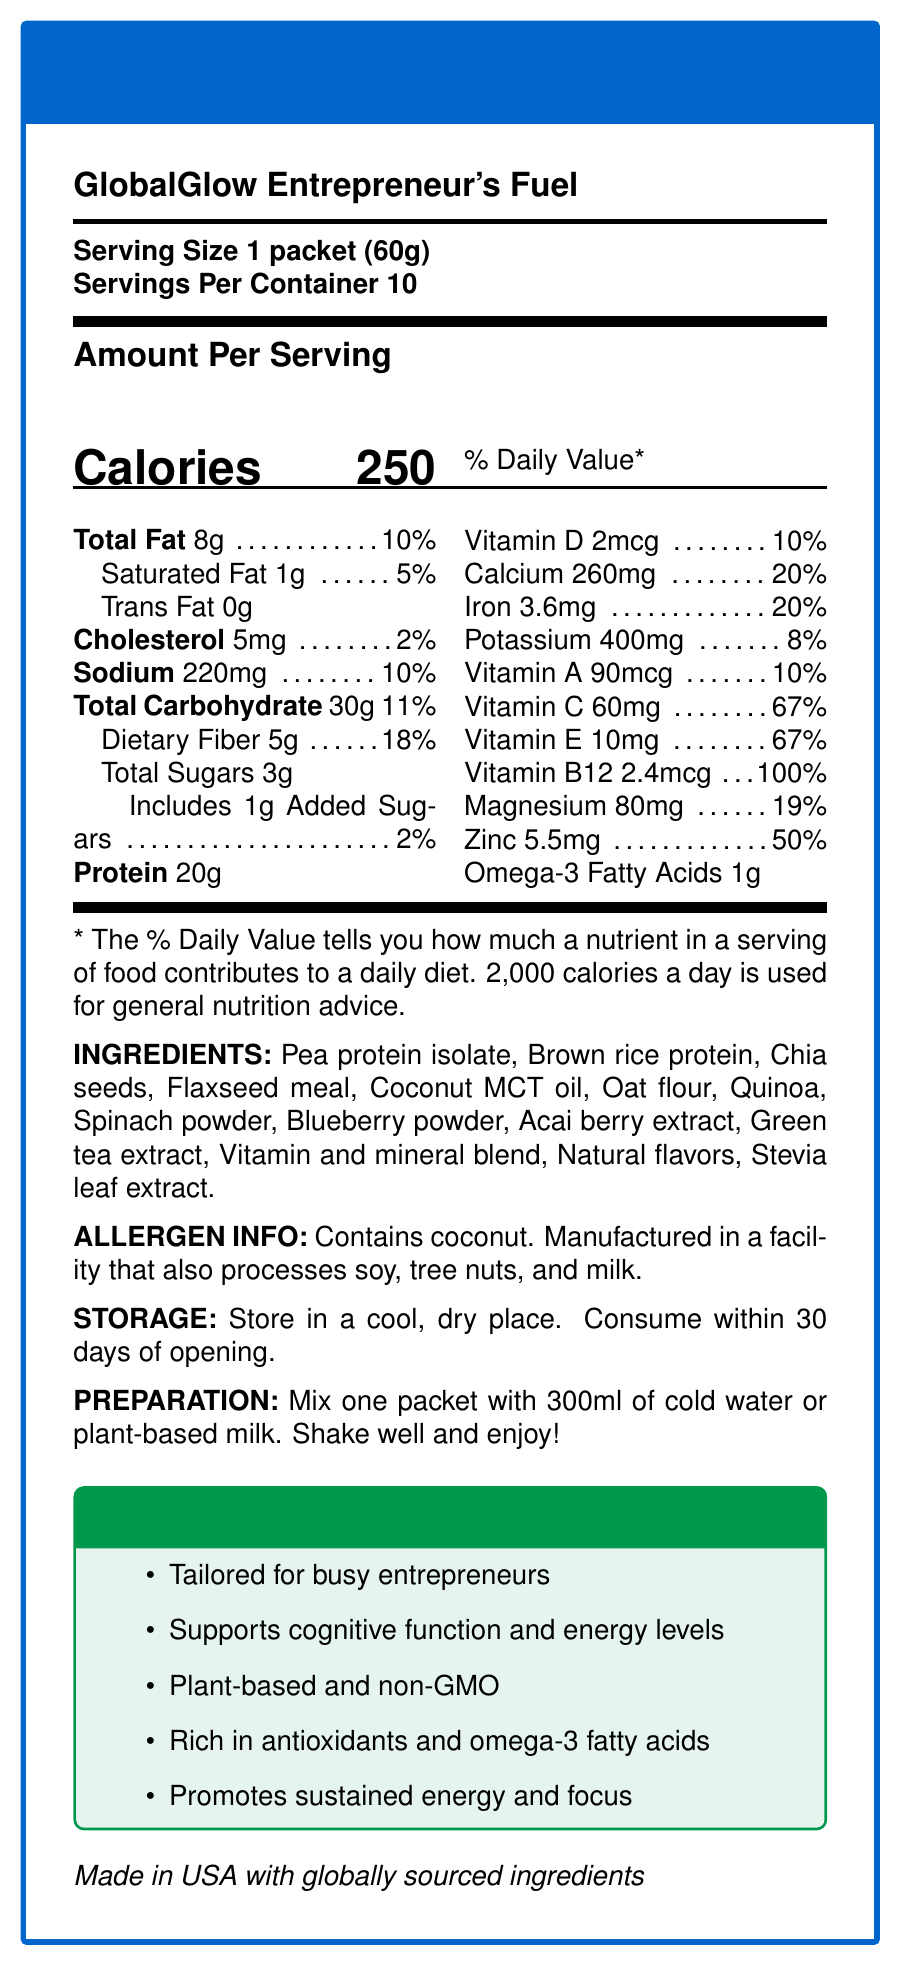What is the serving size of GlobalGlow Entrepreneur's Fuel? The document states that the serving size is "1 packet (60g)".
Answer: 1 packet (60g) How many calories are there per serving? The document lists the calories per serving as 250.
Answer: 250 What is the amount of protein per serving? The document mentions that each serving contains 20g of protein.
Answer: 20g What is the daily value percentage for dietary fiber? The daily value for dietary fiber is listed as 18% in the document.
Answer: 18% What are the storage instructions for this product? The document specifies these as the storage instructions.
Answer: Store in a cool, dry place. Consume within 30 days of opening. How many servings are in one container of GlobalGlow Entrepreneur's Fuel? A. 5 B. 10 C. 15 D. 20 The document clearly states "Servings Per Container: 10".
Answer: B. 10 Which vitamin has a daily value percentage of 100% per serving? A. Vitamin A B. Vitamin C C. Vitamin B12 D. Vitamin D The document shows Vitamin B12 has a daily value percentage of 100%.
Answer: C. Vitamin B12 Does the product contain any trans fat? The document states that the trans fat content is 0g.
Answer: No Is the product suitable for someone avoiding soy? The document mentions the allergen info that it is manufactured in a facility that processes soy.
Answer: No Summarize the key features and benefits of GlobalGlow Entrepreneur's Fuel. The document highlights that the product is designed for busy entrepreneurs, supports cognitive function and energy, is plant-based and non-GMO, contains antioxidants and omega-3s, and promotes sustained energy and focus.
Answer: The product is a health-focused meal replacement tailored for busy entrepreneurs, offering cognitive support, energy levels, and rich in antioxidants and omega-3 fatty acids. It is plant-based, non-GMO, and provides a balanced nutritional profile per serving, including protein, fiber, vitamins, and minerals. Does the document provide the amount of Omega-6 fatty acids in the product? The document provides information only about the Omega-3 fatty acids and does not mention Omega-6 fatty acids.
Answer: Not enough information 